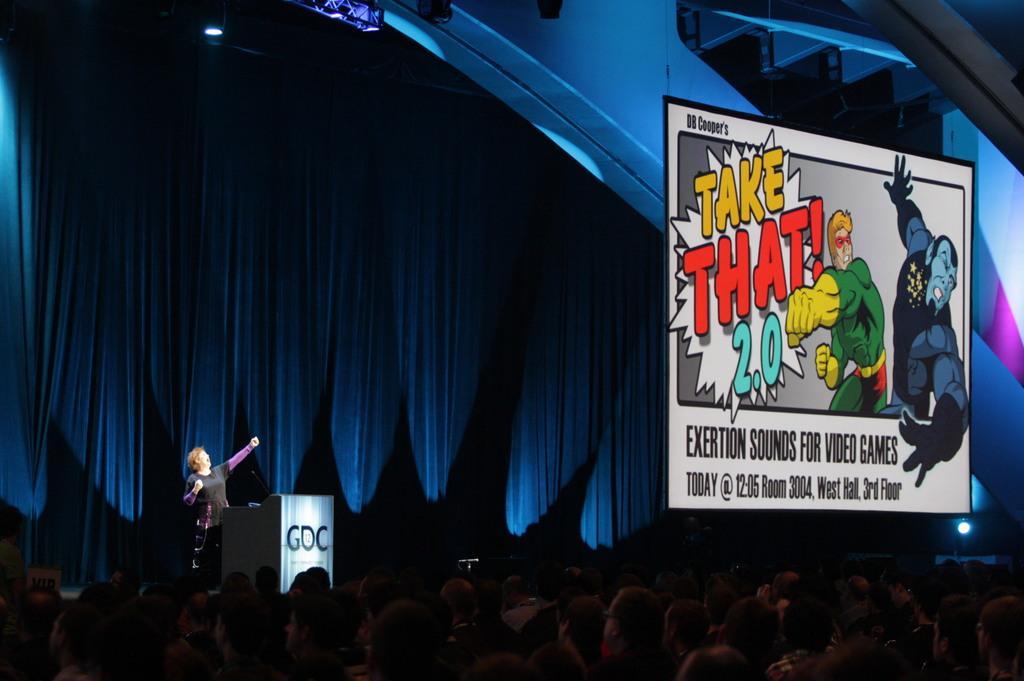How would you summarize this image in a sentence or two? In this image there is a person standing and we can see a podium. At the bottom there are people and we can see a board. In the background there is a curtain and we can see lights. 